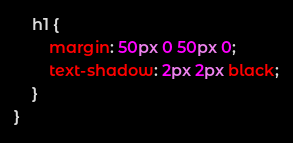Convert code to text. <code><loc_0><loc_0><loc_500><loc_500><_CSS_>    h1 {
        margin: 50px 0 50px 0;
        text-shadow: 2px 2px black;
    }
}</code> 